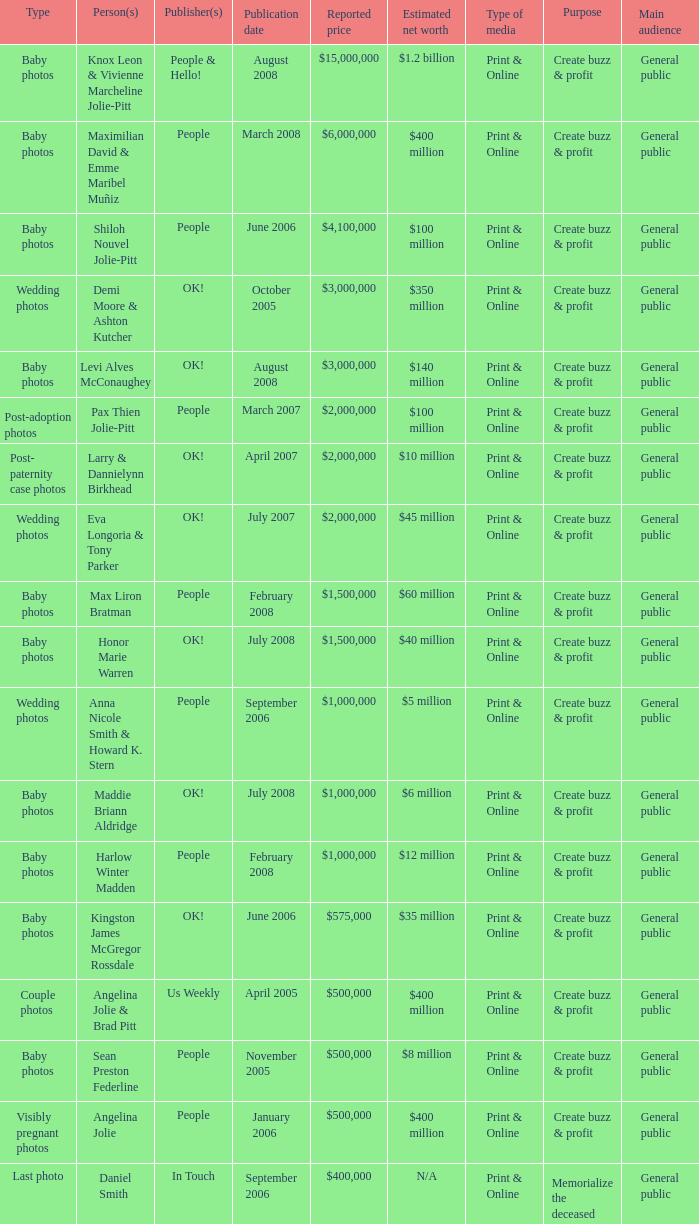What was the publication date of the photos of Sean Preston Federline that cost $500,000 and were published by People? November 2005. 